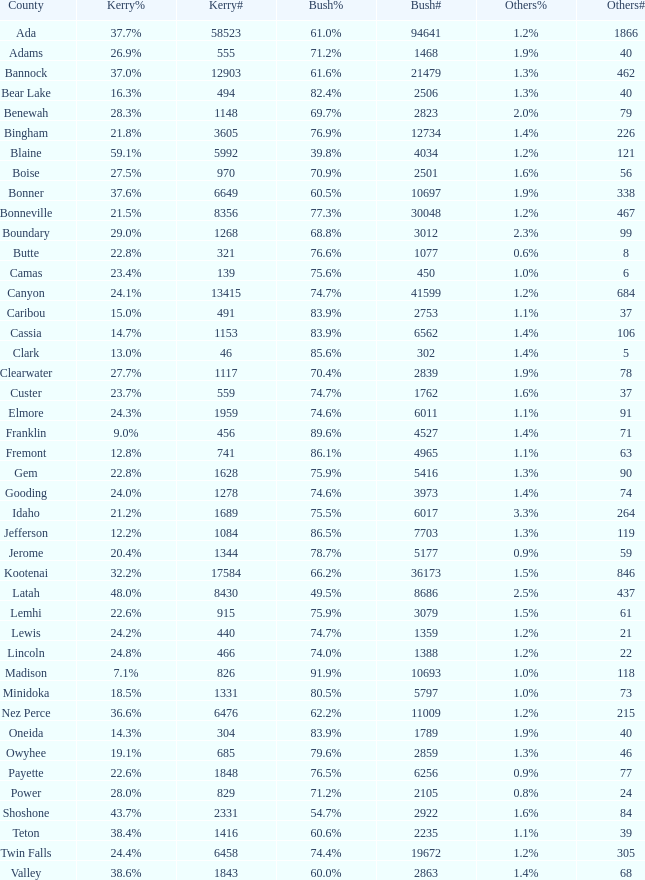In the county where 8 individuals voted for other candidates, how many people cast their votes for kerry? 321.0. Could you parse the entire table as a dict? {'header': ['County', 'Kerry%', 'Kerry#', 'Bush%', 'Bush#', 'Others%', 'Others#'], 'rows': [['Ada', '37.7%', '58523', '61.0%', '94641', '1.2%', '1866'], ['Adams', '26.9%', '555', '71.2%', '1468', '1.9%', '40'], ['Bannock', '37.0%', '12903', '61.6%', '21479', '1.3%', '462'], ['Bear Lake', '16.3%', '494', '82.4%', '2506', '1.3%', '40'], ['Benewah', '28.3%', '1148', '69.7%', '2823', '2.0%', '79'], ['Bingham', '21.8%', '3605', '76.9%', '12734', '1.4%', '226'], ['Blaine', '59.1%', '5992', '39.8%', '4034', '1.2%', '121'], ['Boise', '27.5%', '970', '70.9%', '2501', '1.6%', '56'], ['Bonner', '37.6%', '6649', '60.5%', '10697', '1.9%', '338'], ['Bonneville', '21.5%', '8356', '77.3%', '30048', '1.2%', '467'], ['Boundary', '29.0%', '1268', '68.8%', '3012', '2.3%', '99'], ['Butte', '22.8%', '321', '76.6%', '1077', '0.6%', '8'], ['Camas', '23.4%', '139', '75.6%', '450', '1.0%', '6'], ['Canyon', '24.1%', '13415', '74.7%', '41599', '1.2%', '684'], ['Caribou', '15.0%', '491', '83.9%', '2753', '1.1%', '37'], ['Cassia', '14.7%', '1153', '83.9%', '6562', '1.4%', '106'], ['Clark', '13.0%', '46', '85.6%', '302', '1.4%', '5'], ['Clearwater', '27.7%', '1117', '70.4%', '2839', '1.9%', '78'], ['Custer', '23.7%', '559', '74.7%', '1762', '1.6%', '37'], ['Elmore', '24.3%', '1959', '74.6%', '6011', '1.1%', '91'], ['Franklin', '9.0%', '456', '89.6%', '4527', '1.4%', '71'], ['Fremont', '12.8%', '741', '86.1%', '4965', '1.1%', '63'], ['Gem', '22.8%', '1628', '75.9%', '5416', '1.3%', '90'], ['Gooding', '24.0%', '1278', '74.6%', '3973', '1.4%', '74'], ['Idaho', '21.2%', '1689', '75.5%', '6017', '3.3%', '264'], ['Jefferson', '12.2%', '1084', '86.5%', '7703', '1.3%', '119'], ['Jerome', '20.4%', '1344', '78.7%', '5177', '0.9%', '59'], ['Kootenai', '32.2%', '17584', '66.2%', '36173', '1.5%', '846'], ['Latah', '48.0%', '8430', '49.5%', '8686', '2.5%', '437'], ['Lemhi', '22.6%', '915', '75.9%', '3079', '1.5%', '61'], ['Lewis', '24.2%', '440', '74.7%', '1359', '1.2%', '21'], ['Lincoln', '24.8%', '466', '74.0%', '1388', '1.2%', '22'], ['Madison', '7.1%', '826', '91.9%', '10693', '1.0%', '118'], ['Minidoka', '18.5%', '1331', '80.5%', '5797', '1.0%', '73'], ['Nez Perce', '36.6%', '6476', '62.2%', '11009', '1.2%', '215'], ['Oneida', '14.3%', '304', '83.9%', '1789', '1.9%', '40'], ['Owyhee', '19.1%', '685', '79.6%', '2859', '1.3%', '46'], ['Payette', '22.6%', '1848', '76.5%', '6256', '0.9%', '77'], ['Power', '28.0%', '829', '71.2%', '2105', '0.8%', '24'], ['Shoshone', '43.7%', '2331', '54.7%', '2922', '1.6%', '84'], ['Teton', '38.4%', '1416', '60.6%', '2235', '1.1%', '39'], ['Twin Falls', '24.4%', '6458', '74.4%', '19672', '1.2%', '305'], ['Valley', '38.6%', '1843', '60.0%', '2863', '1.4%', '68']]} 